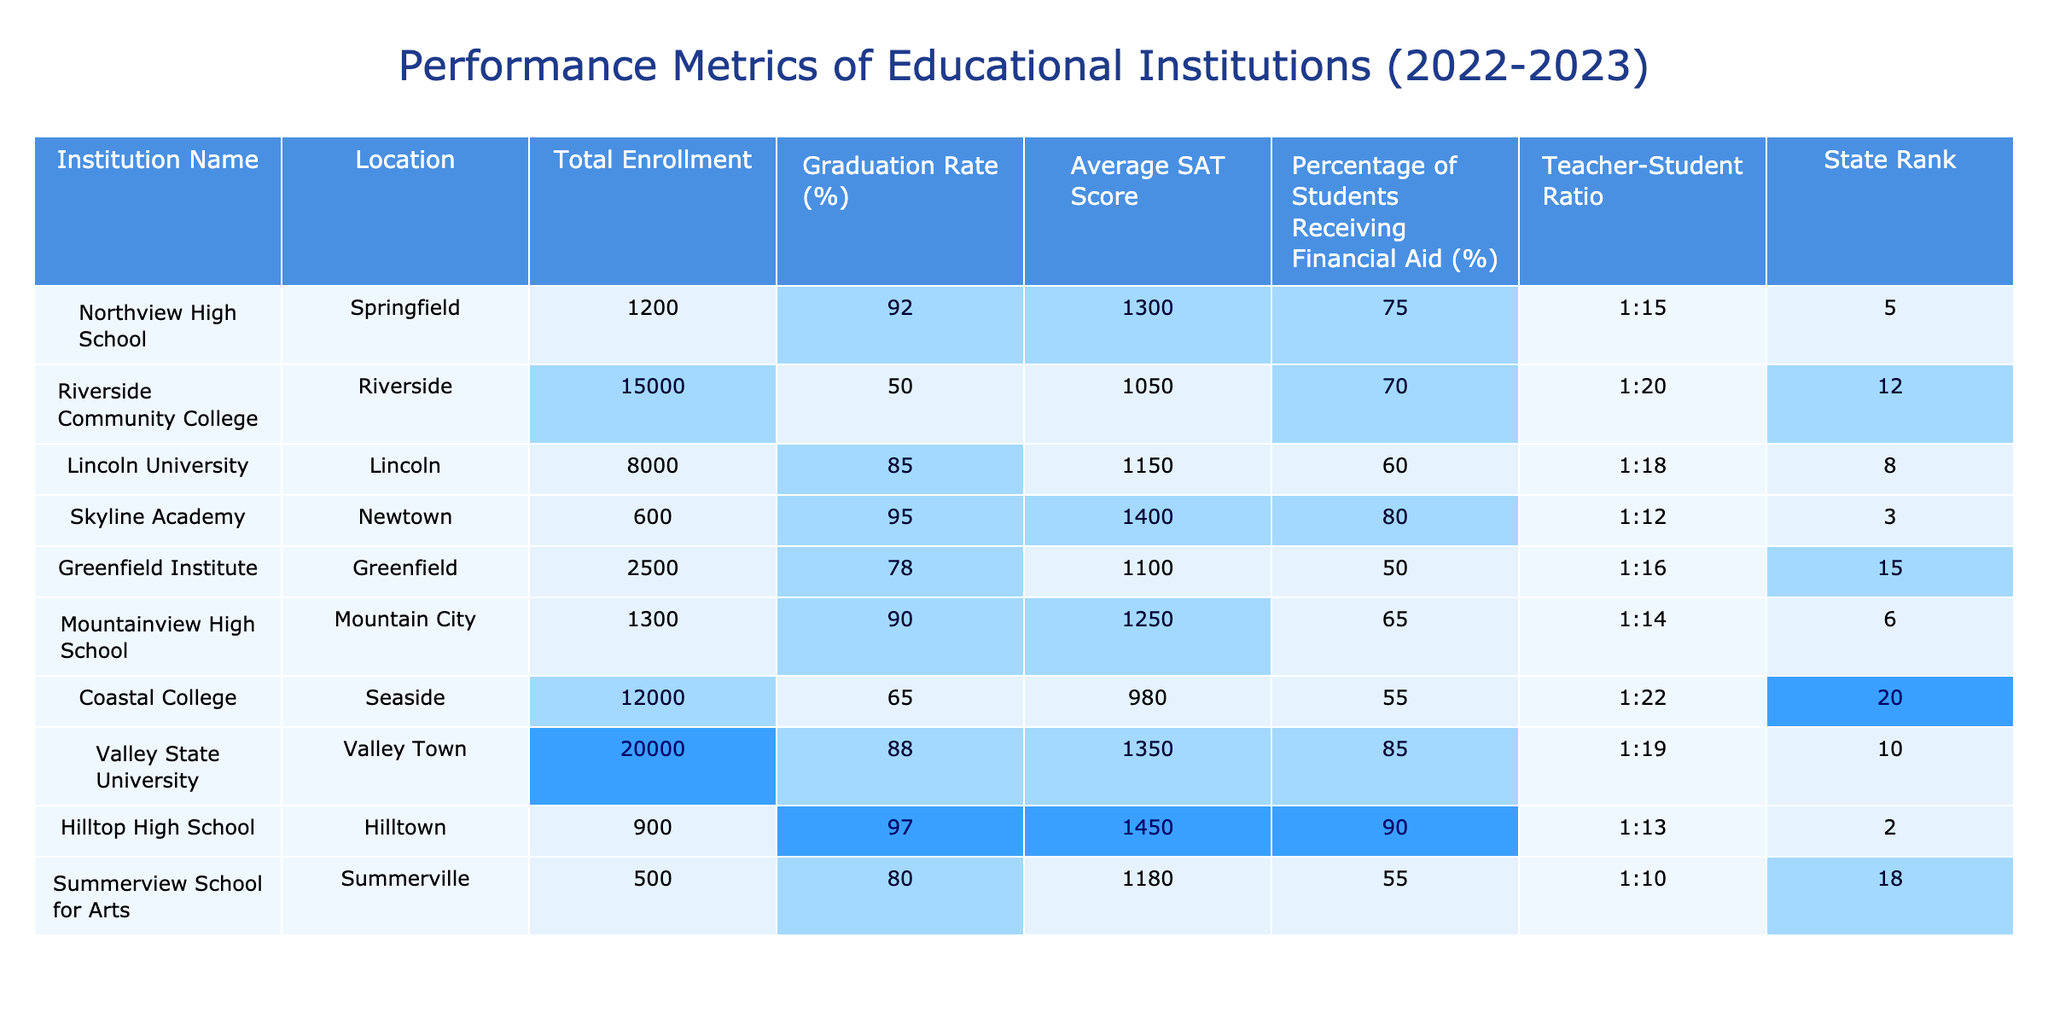What is the graduation rate of Hilltop High School? The table indicates that the graduation rate for Hilltop High School is 97%.
Answer: 97% Which institution has the lowest average SAT score? By examining the Average SAT Score column, Coastal College has the lowest score at 980.
Answer: 980 What is the total enrollment of Valley State University and Coastal College combined? The total enrollment for Valley State University is 20,000 and for Coastal College is 12,000. Adding these together gives 20,000 + 12,000 = 32,000.
Answer: 32,000 Is there any institution with a graduation rate above 90%? The table shows that Skyline Academy (95%), Hilltop High School (97%), and Northview High School (92%) have graduation rates above 90%.
Answer: Yes What is the average graduation rate of the institutions listed? To calculate the average, sum the graduation rates: 92 + 50 + 85 + 95 + 78 + 90 + 65 + 88 + 97 + 80, which totals 930. Dividing by 10 institutions gives an average of 930 / 10 = 93%.
Answer: 93% Which institution has the highest value for the percentage of students receiving financial aid? By looking at the Percentage of Students Receiving Financial Aid (%) column, Valley State University has the highest value at 85%.
Answer: 85% What is the teacher-student ratio at Lincoln University? The table indicates that Lincoln University has a teacher-student ratio of 1:18.
Answer: 1:18 If we consider only the top three institutions by state rank, what is their average SAT score? The top three institutions are Northview High School (1300), Skyline Academy (1400), and Hilltop High School (1450). The total is 1300 + 1400 + 1450 = 4150. Dividing by 3 gives an average SAT score of 4150 / 3 = 1383.33.
Answer: 1383.33 Are there more institutions with a student-teacher ratio worse than 1:20? There are three institutions listed: Riverside Community College (1:20), Coastal College (1:22), and Greenfield Institute (1:16), which means there are two with a worse ratio than 1:20.
Answer: Yes What is the difference in graduation rates between Northview High School and Coastal College? Northview High School has a graduation rate of 92%, while Coastal College has a rate of 65%. The difference is 92 - 65 = 27 percentage points.
Answer: 27 